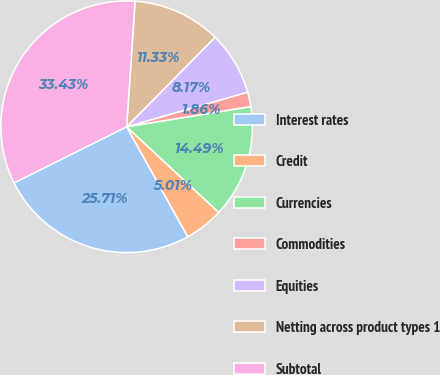<chart> <loc_0><loc_0><loc_500><loc_500><pie_chart><fcel>Interest rates<fcel>Credit<fcel>Currencies<fcel>Commodities<fcel>Equities<fcel>Netting across product types 1<fcel>Subtotal<nl><fcel>25.71%<fcel>5.01%<fcel>14.49%<fcel>1.86%<fcel>8.17%<fcel>11.33%<fcel>33.43%<nl></chart> 